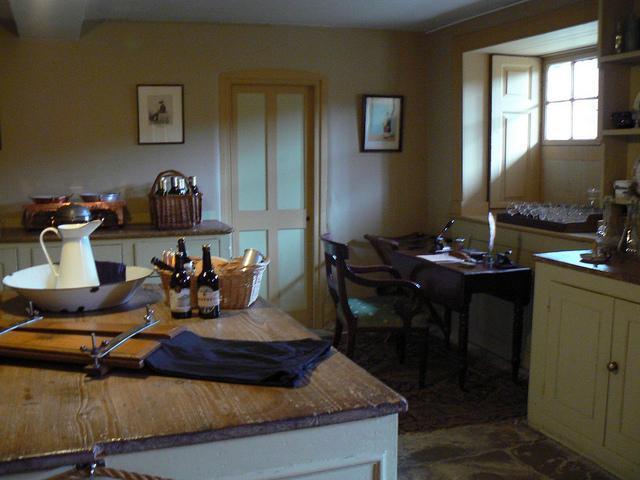How many pictures are hanging on the wall?
Choose the right answer from the provided options to respond to the question.
Options: Six, four, two, one. Two. 